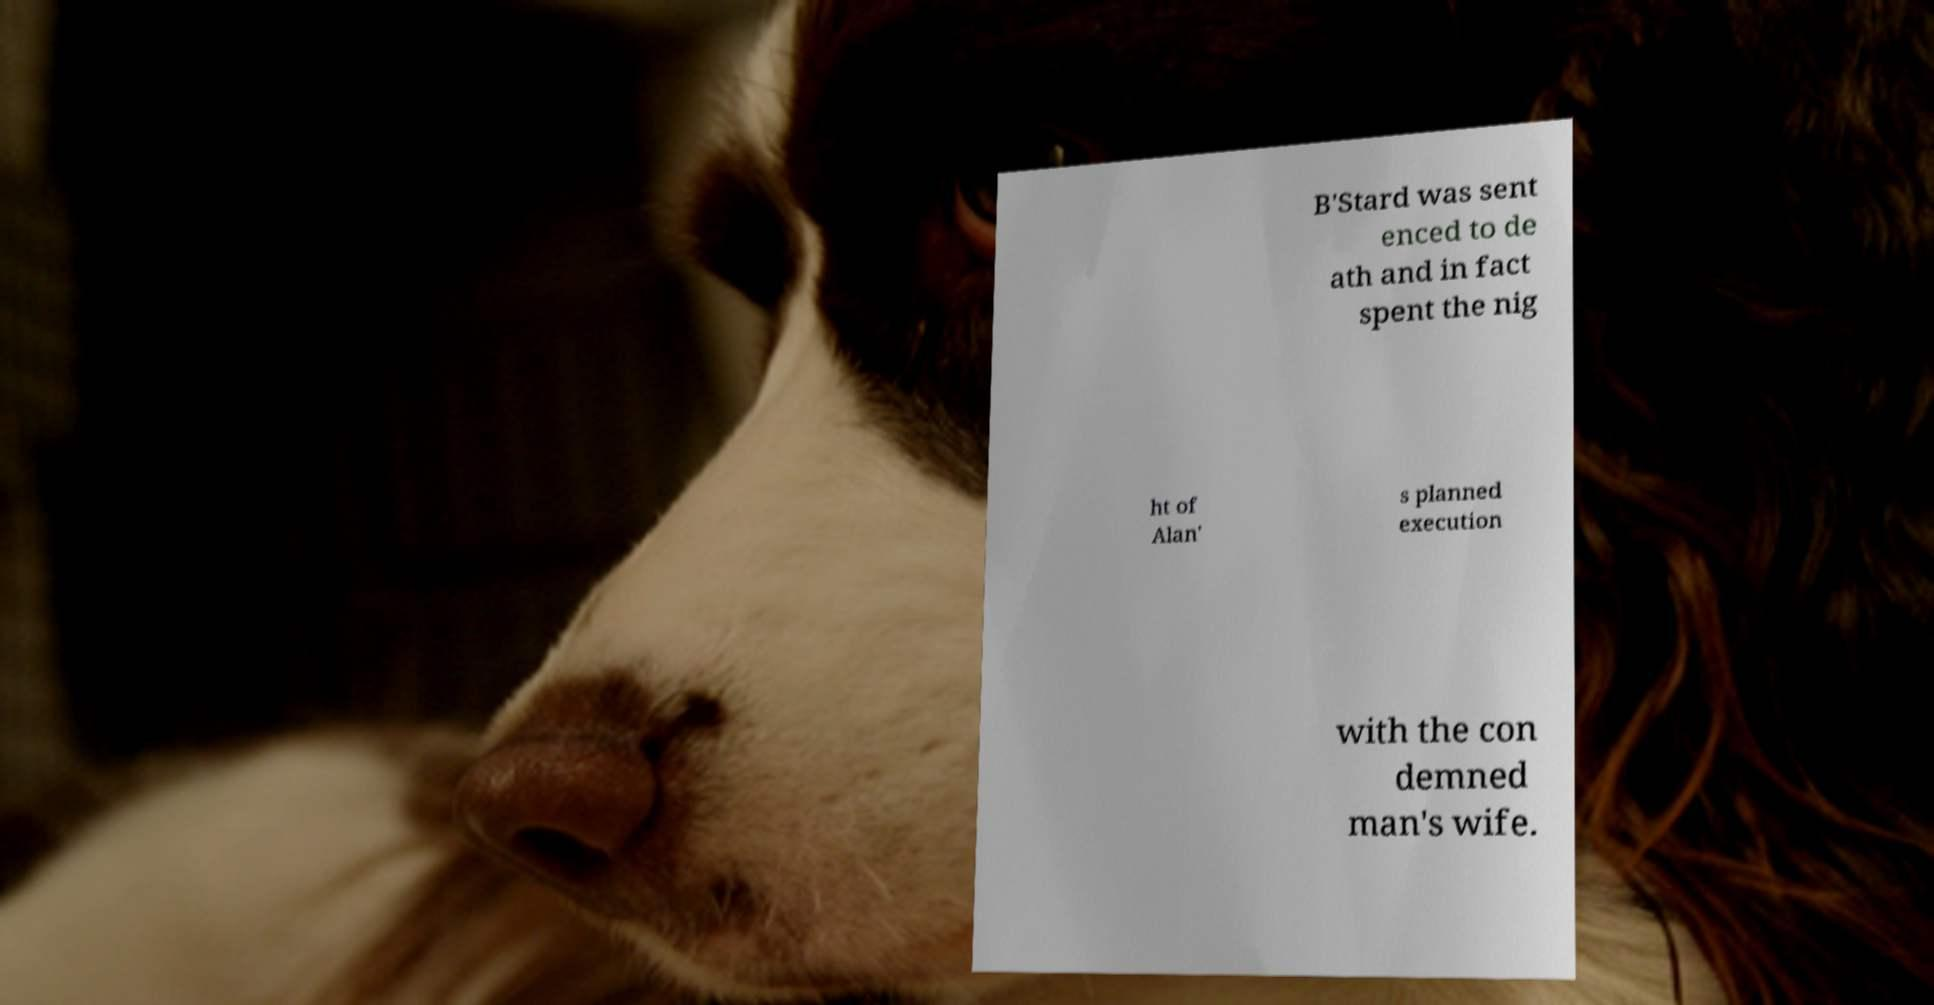Could you assist in decoding the text presented in this image and type it out clearly? B'Stard was sent enced to de ath and in fact spent the nig ht of Alan' s planned execution with the con demned man's wife. 